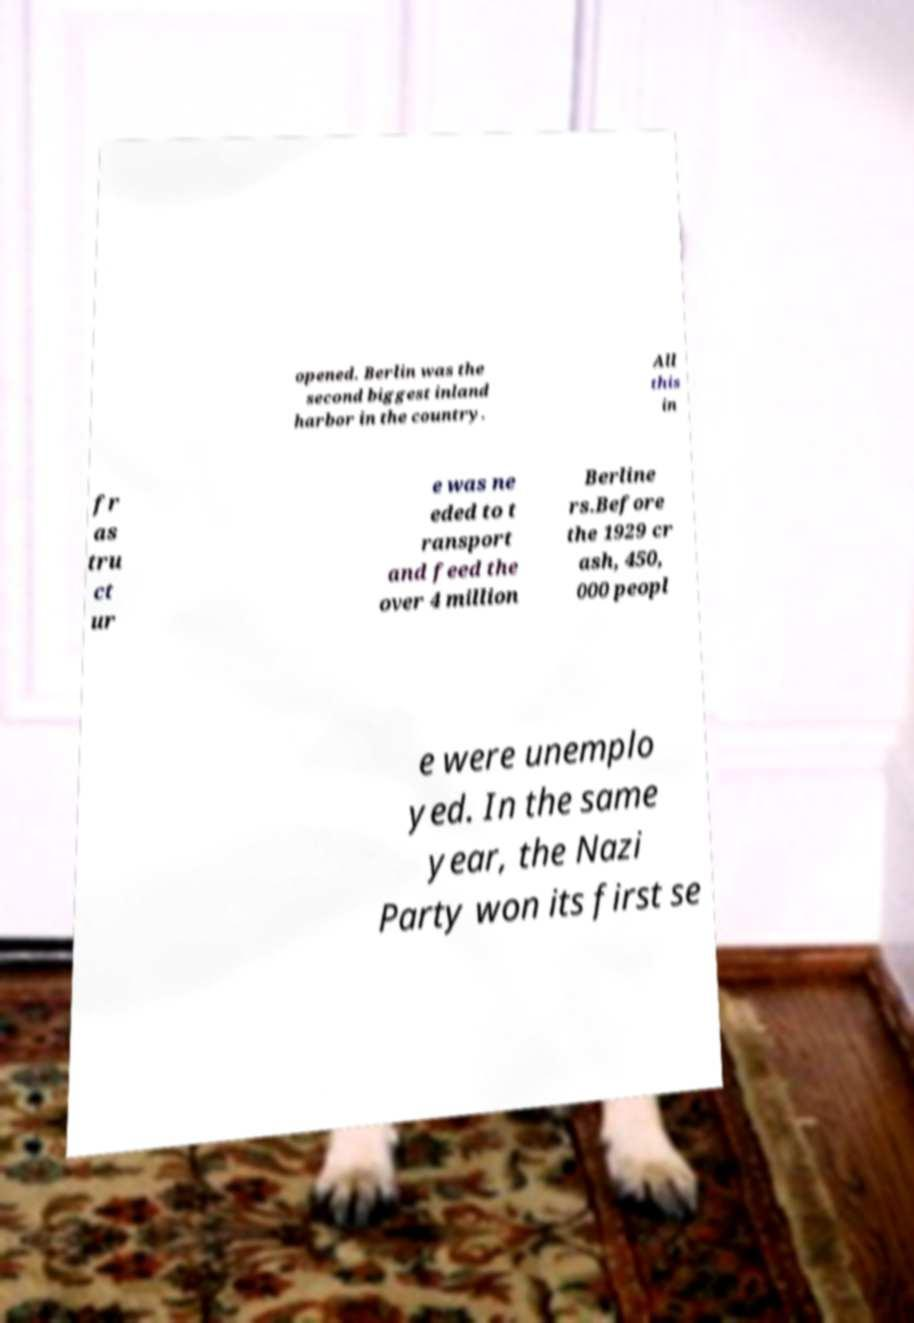Please read and relay the text visible in this image. What does it say? opened. Berlin was the second biggest inland harbor in the country. All this in fr as tru ct ur e was ne eded to t ransport and feed the over 4 million Berline rs.Before the 1929 cr ash, 450, 000 peopl e were unemplo yed. In the same year, the Nazi Party won its first se 